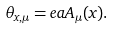Convert formula to latex. <formula><loc_0><loc_0><loc_500><loc_500>\theta _ { x , \mu } = e a A _ { \mu } ( x ) .</formula> 